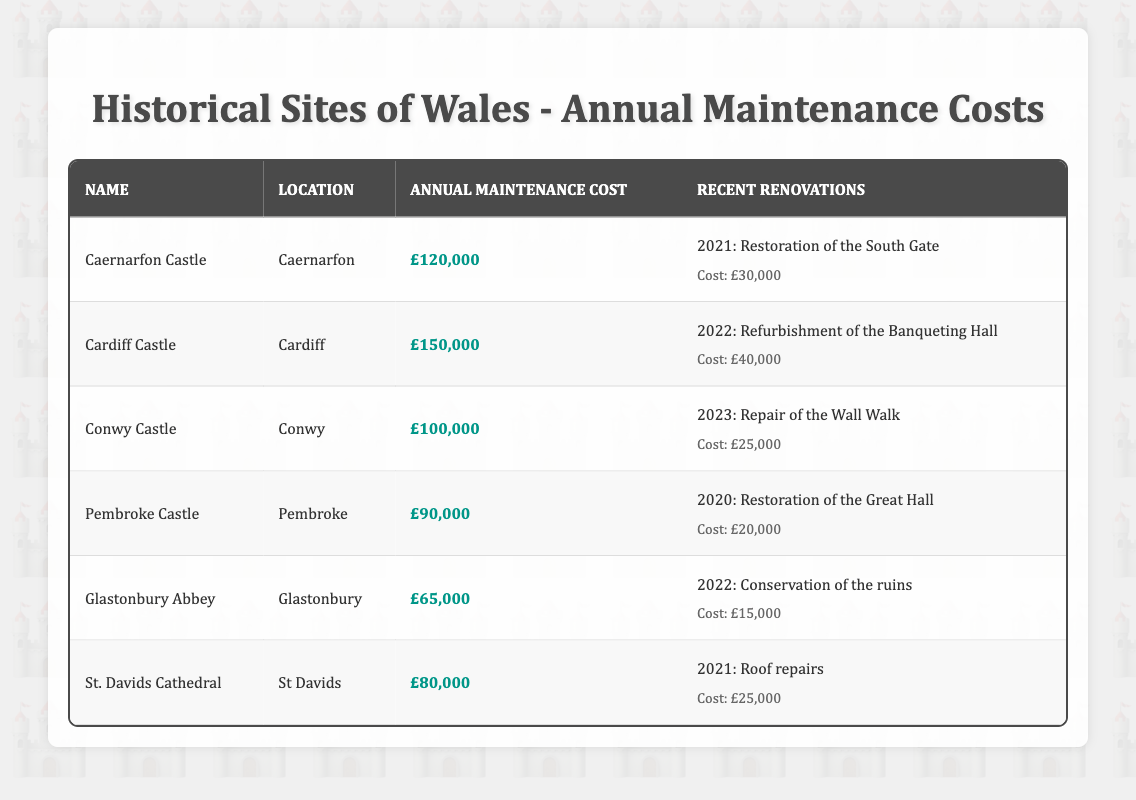What is the annual maintenance cost of Cardiff Castle? The table shows that Cardiff Castle has an annual maintenance cost highlighted as £150,000.
Answer: £150,000 Which historical site has the lowest annual maintenance cost? In the table, Glastonbury Abbey has the lowest annual maintenance cost at £65,000.
Answer: £65,000 How much did St. Davids Cathedral spend on roof repairs? The renovation details for St. Davids Cathedral state that the cost of roof repairs in 2021 was £25,000.
Answer: £25,000 What is the total annual maintenance cost of all sites in the table? The total can be calculated by summing the annual maintenance costs: £120,000 + £150,000 + £100,000 + £90,000 + £65,000 + £80,000 = £605,000.
Answer: £605,000 Did Conwy Castle have any renovations in 2022? The table indicates that Conwy Castle's recent renovation was in 2023 for £25,000, so there were no renovations in 2022.
Answer: No What is the difference between the annual maintenance costs of Cardiff Castle and Glastonbury Abbey? The difference can be calculated by subtracting the costs: £150,000 (Cardiff Castle) - £65,000 (Glastonbury Abbey) = £85,000.
Answer: £85,000 How many historical sites have annual maintenance costs above £100,000? By examining the table, Cardiff Castle (£150,000) and Caernarfon Castle (£120,000) are above £100,000; therefore, there are 2 sites.
Answer: 2 What is the average annual maintenance cost of the historical sites listed? The average cost can be computed by summing the costs (£605,000) and dividing by the number of sites (6): £605,000 / 6 = £100,833.33, which we can round to £100,833.
Answer: Approximately £100,833 Which site underwent restoration of the Great Hall? The table indicates that Pembroke Castle underwent restoration of the Great Hall in 2020.
Answer: Pembroke Castle Is there any site with an annual maintenance cost of exactly £90,000? Yes, the table shows that Pembroke Castle has an annual maintenance cost of £90,000.
Answer: Yes 